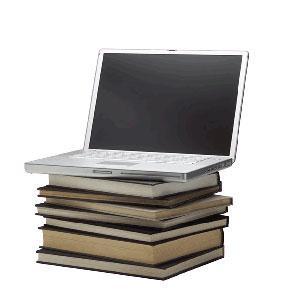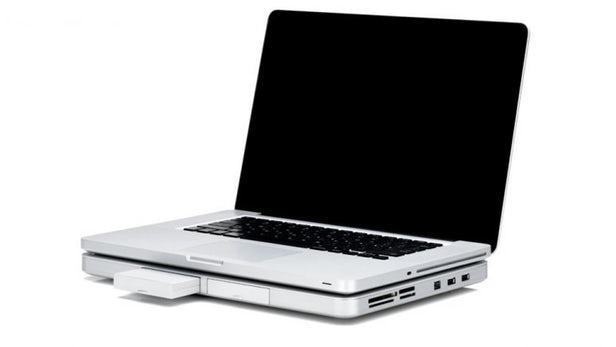The first image is the image on the left, the second image is the image on the right. Analyze the images presented: Is the assertion "An open laptop is sitting on a stack of at least three rectangular items in the left image." valid? Answer yes or no. Yes. 